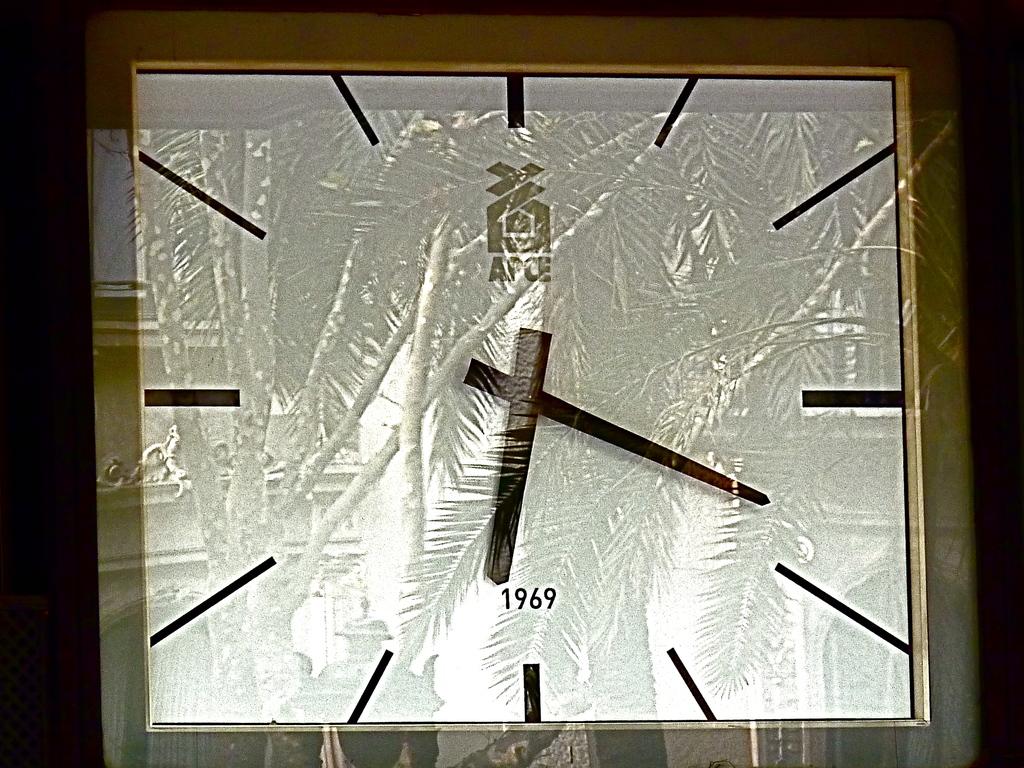What is the word above the clock hands?
Your response must be concise. Apce. 